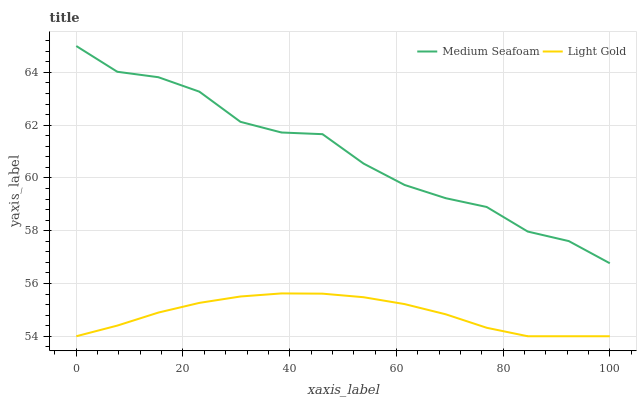Does Light Gold have the minimum area under the curve?
Answer yes or no. Yes. Does Medium Seafoam have the maximum area under the curve?
Answer yes or no. Yes. Does Medium Seafoam have the minimum area under the curve?
Answer yes or no. No. Is Light Gold the smoothest?
Answer yes or no. Yes. Is Medium Seafoam the roughest?
Answer yes or no. Yes. Is Medium Seafoam the smoothest?
Answer yes or no. No. Does Light Gold have the lowest value?
Answer yes or no. Yes. Does Medium Seafoam have the lowest value?
Answer yes or no. No. Does Medium Seafoam have the highest value?
Answer yes or no. Yes. Is Light Gold less than Medium Seafoam?
Answer yes or no. Yes. Is Medium Seafoam greater than Light Gold?
Answer yes or no. Yes. Does Light Gold intersect Medium Seafoam?
Answer yes or no. No. 